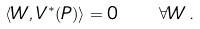<formula> <loc_0><loc_0><loc_500><loc_500>\langle W , V ^ { \ast } ( P ) \rangle = 0 \quad \forall W \, .</formula> 